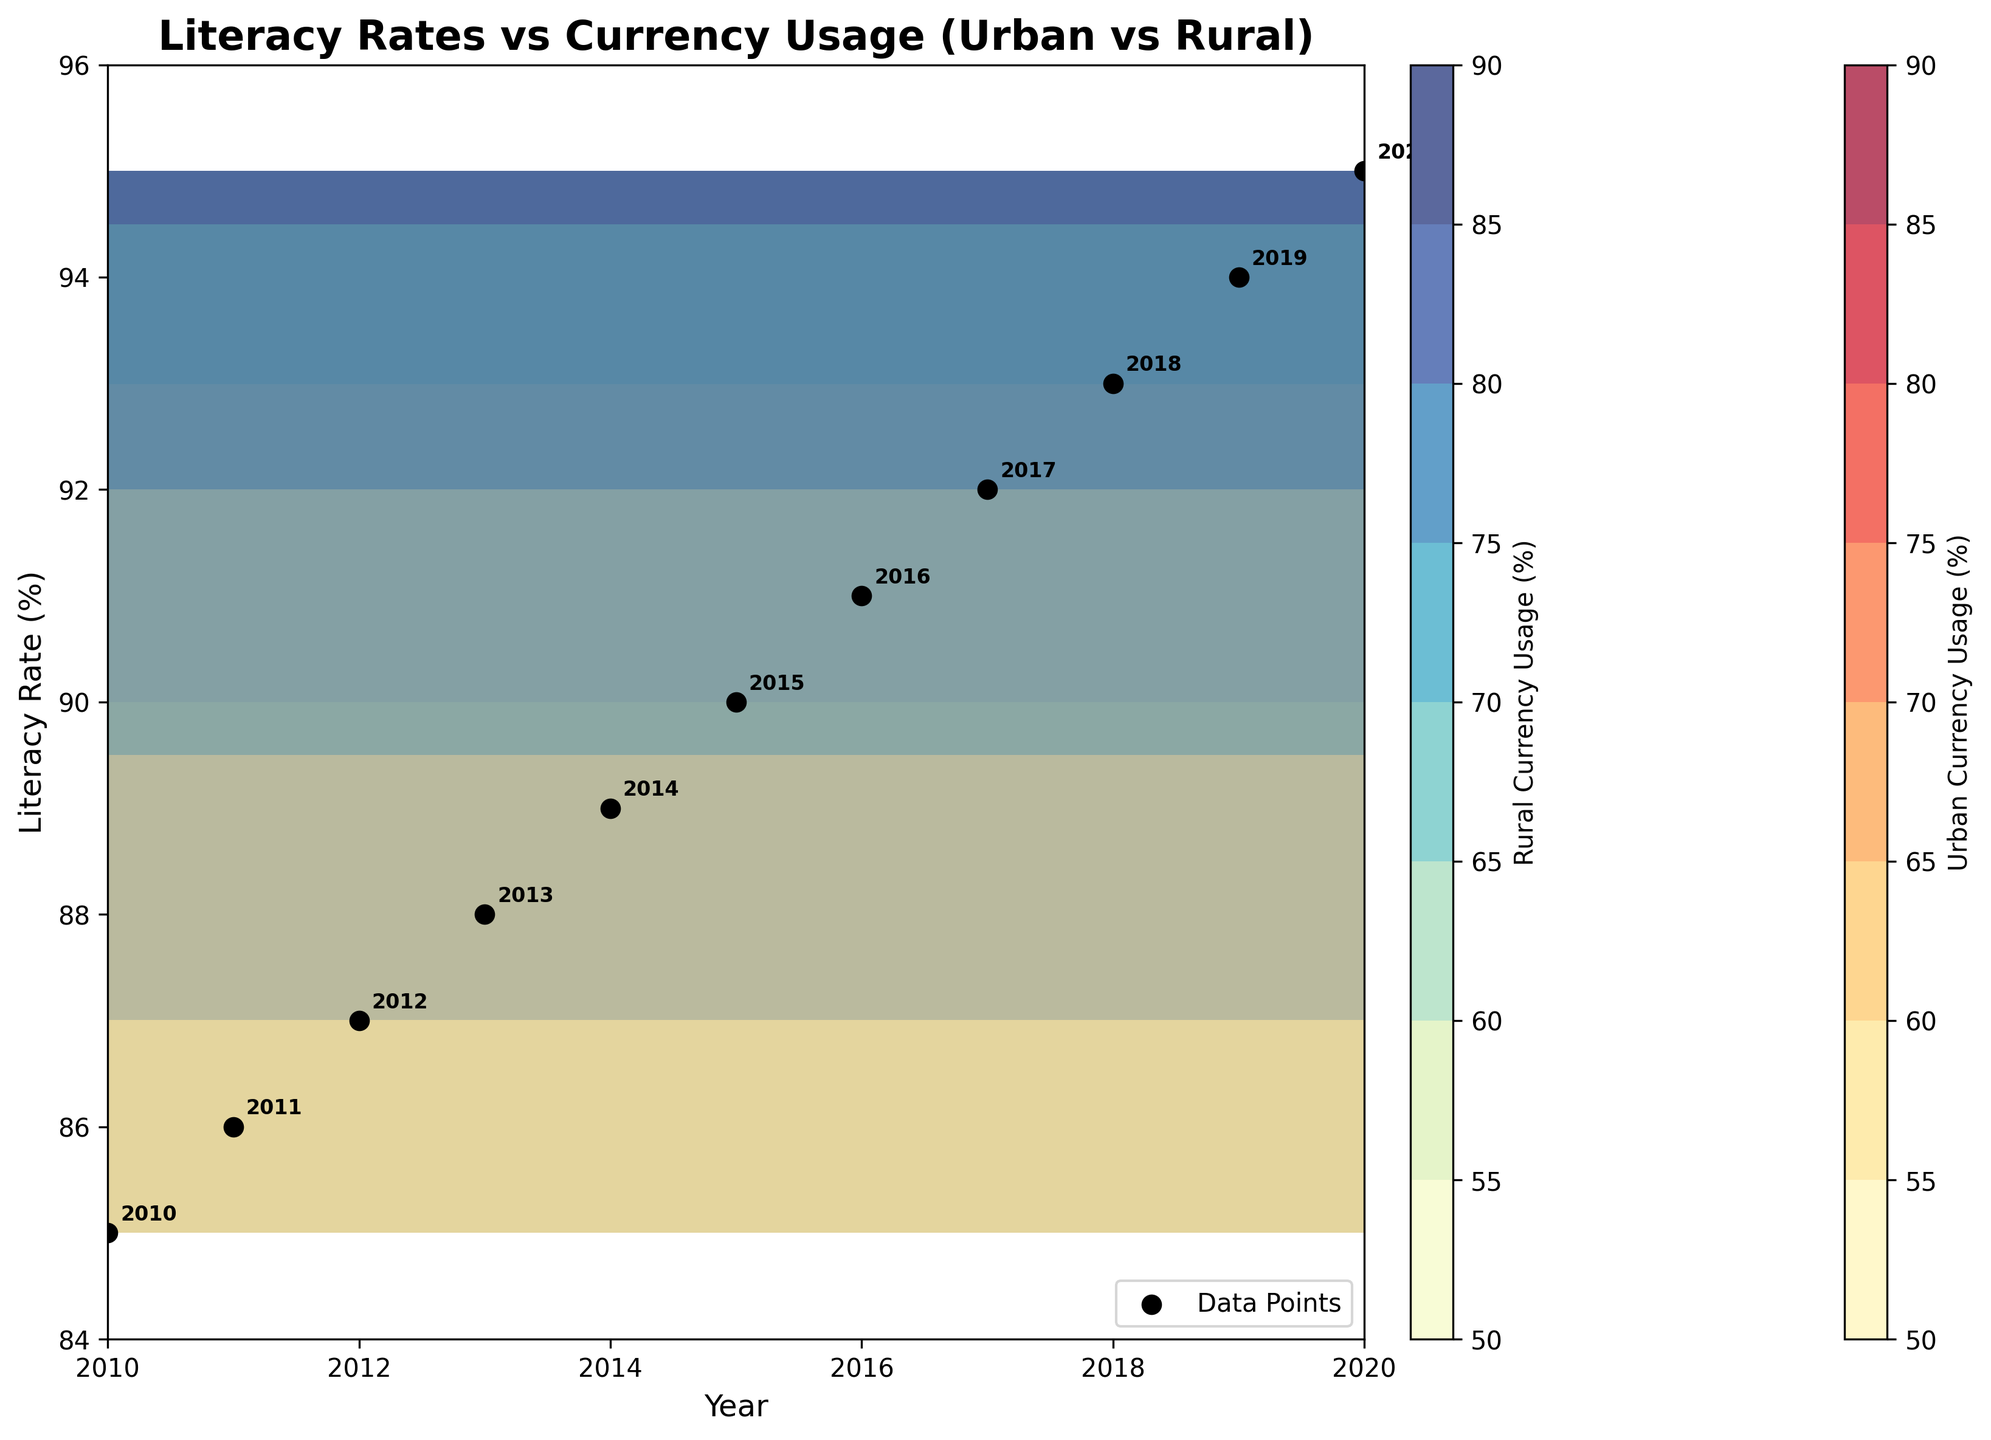What's the title of the plot? The title is displayed at the top center of the plot, which reads 'Literacy Rates vs Currency Usage (Urban vs Rural)'.
Answer: Literacy Rates vs Currency Usage (Urban vs Rural) What does the y-axis represent? The y-axis label is shown as 'Literacy Rate (%)', indicating that it represents literacy rates in percentage terms.
Answer: Literacy Rate (%) What's the color scheme used for urban currency usage? The color scheme for urban currency usage is indicated by the colorbar labeled 'Urban Currency Usage (%)' on the right, using a gradient from yellow to red.
Answer: Yellow to Red How many data points are plotted on the chart? Data points appear as black scatter points on the plot. Counting them reveals there are data points for each year from 2010 to 2020, making a total of 11 data points.
Answer: 11 For which year does the rural currency usage reach around 74%, as seen in the contour plot? Examining the contour lines for rural currency usage and matching labels in the color scheme, 74% usage happens in the year 2019.
Answer: 2019 Compare the urban and rural currency usages in the year 2012. Which is higher? For the year 2012, urban currency usage is 75%, and rural currency usage is 60% (based on the data points and interpolation). Urban usage is higher than rural.
Answer: Urban Identify the year with the highest urban currency usage. According to the contour plot and the data points, the highest urban currency usage occurs in the year 2020 with 89%.
Answer: 2020 Does the rural currency usage ever exceed 75%? By analyzing the contour plot and the colorbar with rural data levels, it shows rural currency usage does not exceed 75% throughout the years presented.
Answer: No How does the trend of literacy rates compare to urban currency usage over the years? Both literacy rates and urban currency usage show an increasing trend from 2010 to 2020. The contours and scatter points indicate a positive correlation.
Answer: Increasing Which year exhibits closer values between rural and urban currency usage according to the contour plots? Comparing contours and the color gradients, the smallest gap appears around the year 2010 where urban is 70% and rural is 55%, a 15% difference.
Answer: 2010 